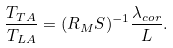Convert formula to latex. <formula><loc_0><loc_0><loc_500><loc_500>\frac { T _ { T A } } { T _ { L A } } = ( R _ { M } S ) ^ { - 1 } \frac { \lambda _ { c o r } } { L } .</formula> 